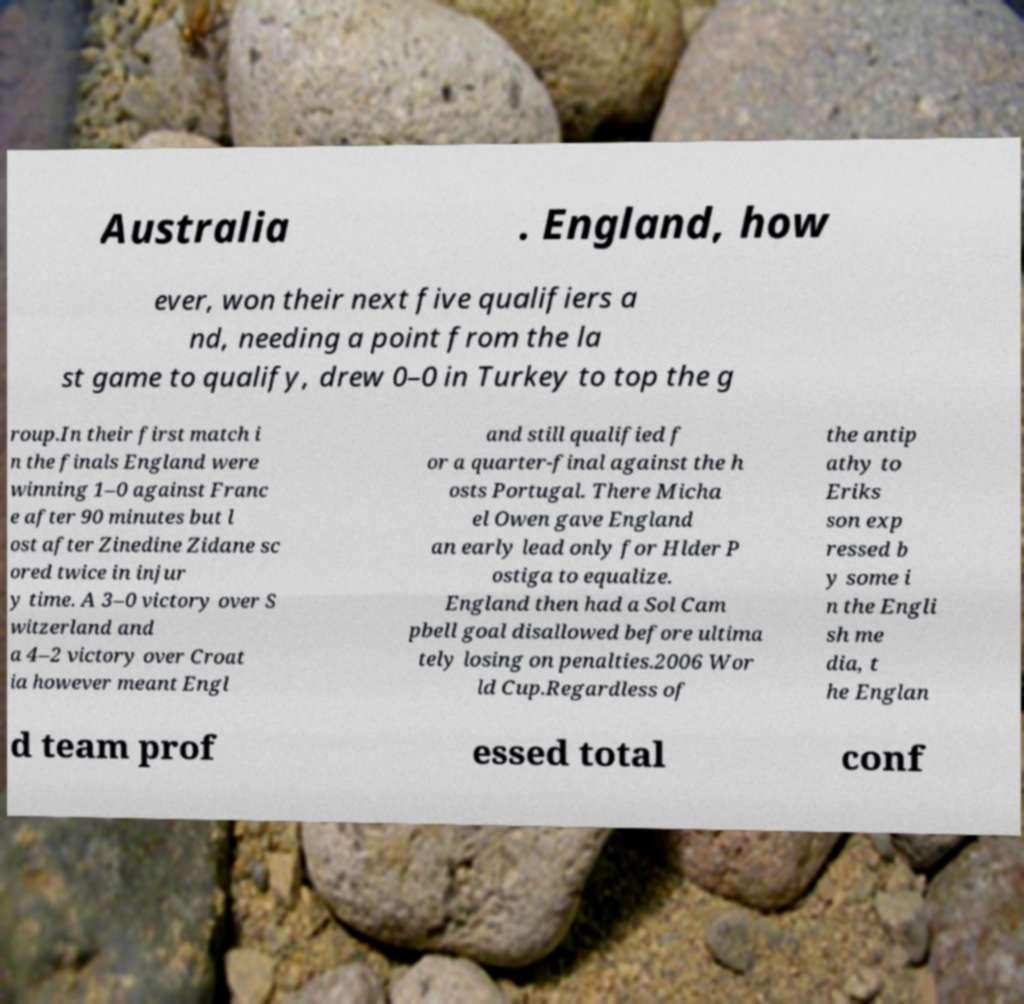Could you extract and type out the text from this image? Australia . England, how ever, won their next five qualifiers a nd, needing a point from the la st game to qualify, drew 0–0 in Turkey to top the g roup.In their first match i n the finals England were winning 1–0 against Franc e after 90 minutes but l ost after Zinedine Zidane sc ored twice in injur y time. A 3–0 victory over S witzerland and a 4–2 victory over Croat ia however meant Engl and still qualified f or a quarter-final against the h osts Portugal. There Micha el Owen gave England an early lead only for Hlder P ostiga to equalize. England then had a Sol Cam pbell goal disallowed before ultima tely losing on penalties.2006 Wor ld Cup.Regardless of the antip athy to Eriks son exp ressed b y some i n the Engli sh me dia, t he Englan d team prof essed total conf 